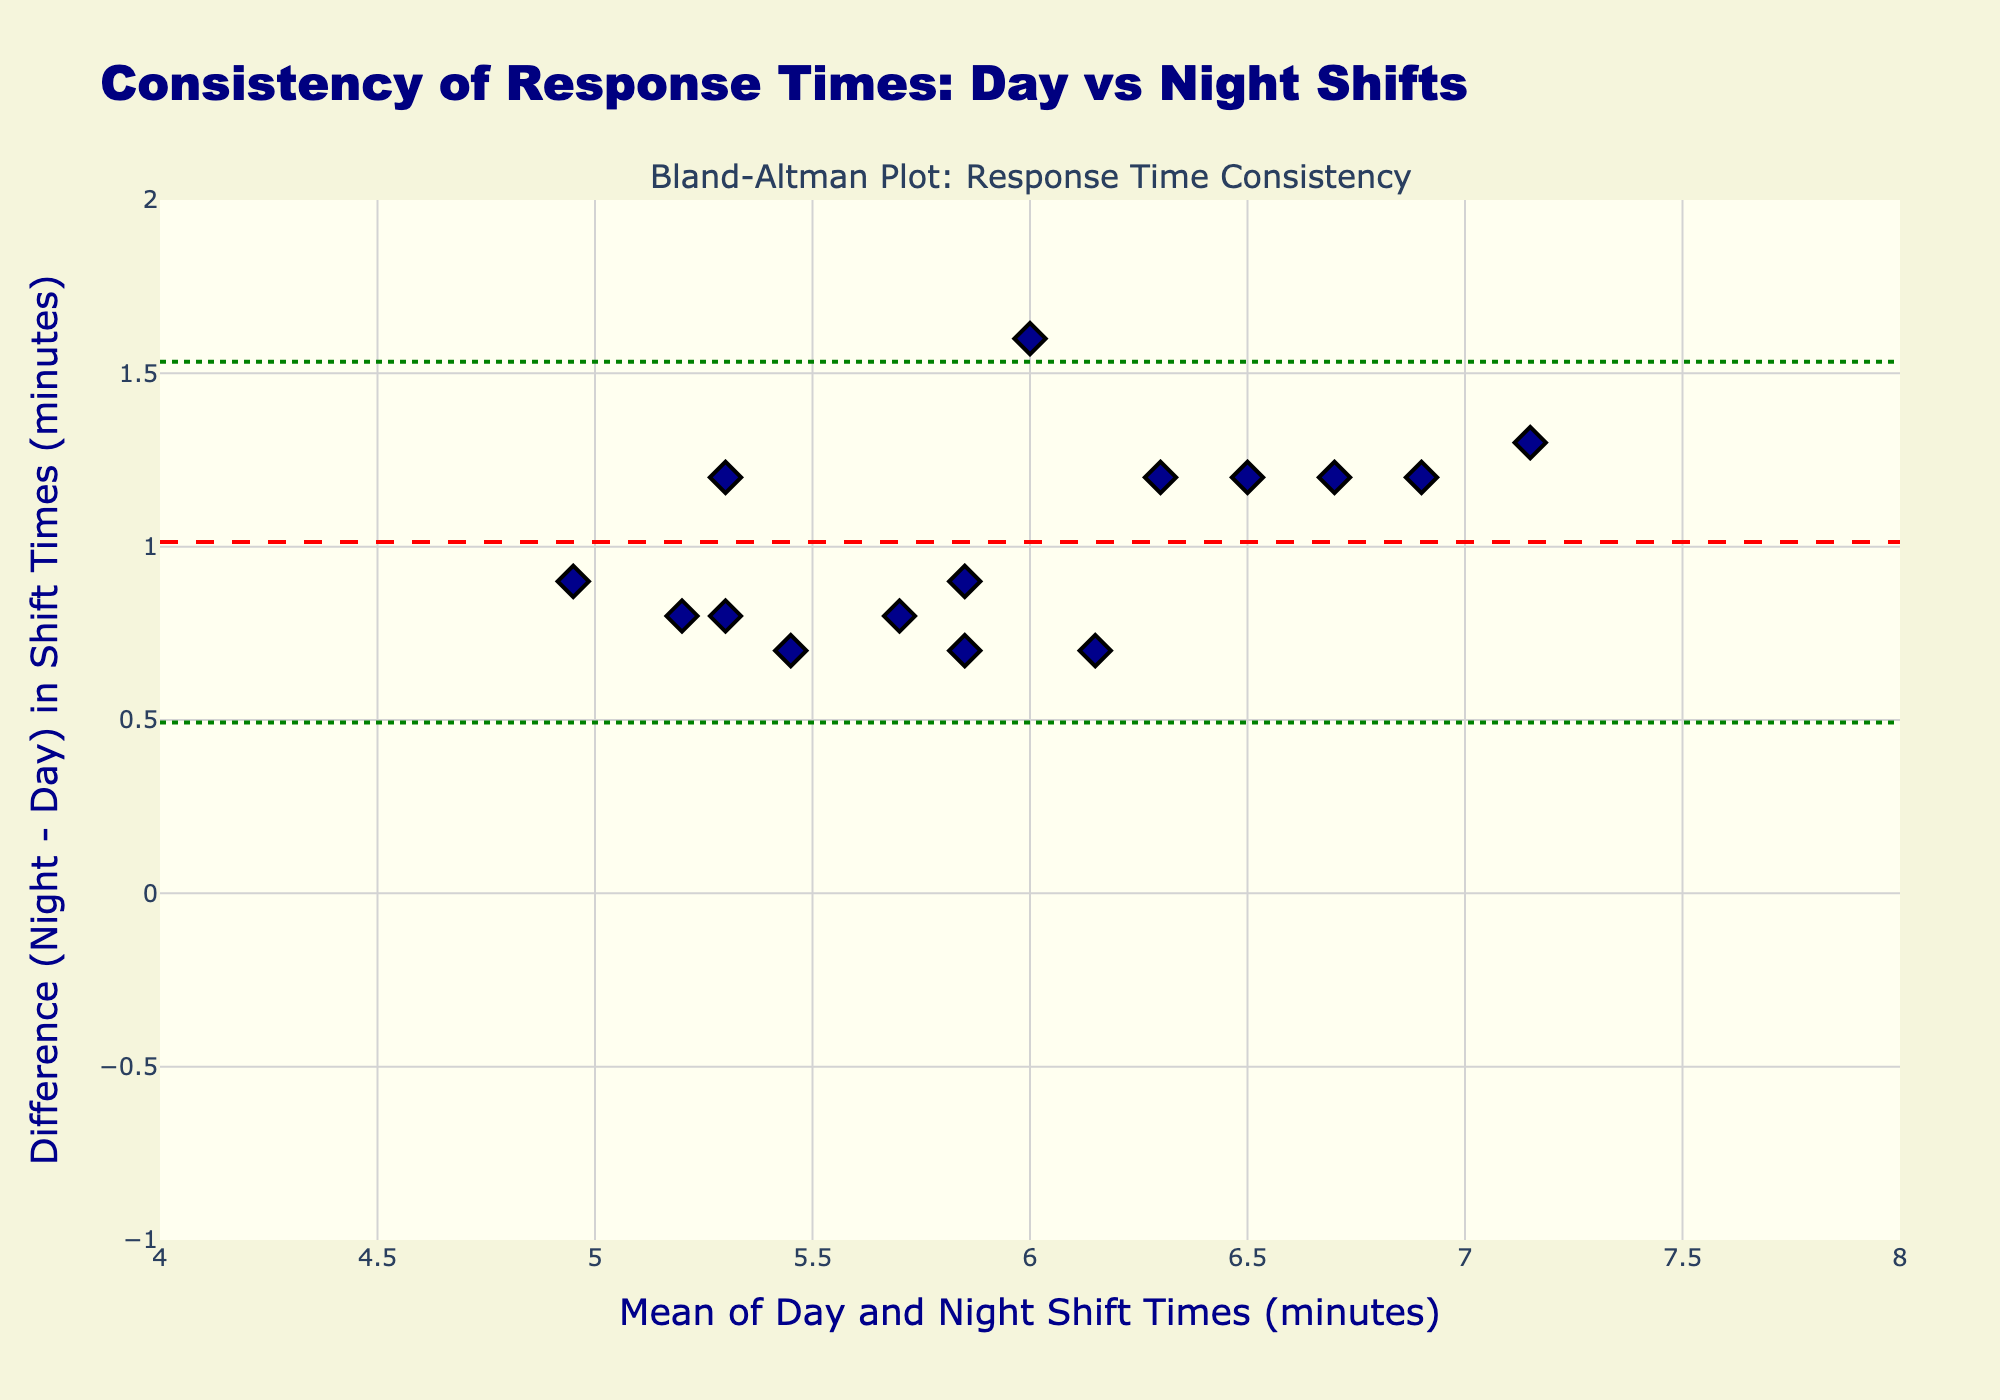What is the title of this plot? The title is located at the top of the figure and is often displayed prominently to describe the nature of the plot's content. Here, it reads "Consistency of Response Times: Day vs Night Shifts".
Answer: Consistency of Response Times: Day vs Night Shifts What are the units on the x-axis and y-axis? The x-axis title mentions "Mean of Day and Night Shift Times (minutes)" and the y-axis title mentions "Difference (Night - Day) in Shift Times (minutes)". Both axes are measured in minutes.
Answer: Minutes How many data points are plotted in the Bland-Altman plot? The data points are the individual markers present in the plot. By counting these markers, we can determine the number of data points. Here, there are 15 markers.
Answer: 15 What is the mean difference between night and day shift times? The mean difference is represented by a dashed red line on the y-axis. Look at the y-coordinate of this line to find the mean difference, which is approximately 1.2 minutes.
Answer: 1.2 What is the range of the 'mean' values on the x-axis? The x-axis range can be identified by observing the start and end values on the x-axis. The values range from approximately 4 to 8 minutes.
Answer: 4 to 8 What does the green dashed line represent? The green dashed lines represent the limits of agreement, defined by the mean difference ± 1.96 times the standard deviation.
Answer: Limits of agreement What are the values for the upper and lower limits of agreement? The upper limit is the sum of the mean difference and 1.96 times the standard deviation, represented by the top green dashed line, approximately 1.6. The lower limit is the difference between the mean difference and 1.96 times the standard deviation, represented by the bottom green dashed line, approximately -0.2.
Answer: Upper: 1.6, Lower: -0.2 What can we infer if most points lie within the limits of agreement? If most data points lie within the limits of agreement (between -0.2 and 1.6), it implies that the response times are consistent between day and night shifts within this range.
Answer: Response times are consistent Are there any data points outside the limits of agreement? Check if any markers fall outside the range of the upper and lower agreement limits (green dashed lines). All points lie within the limits of agreement.
Answer: No Is the overall trend of response time difference between day and night shifts positive or negative? Observe the general positioning of the data points relative to the 0 line on the y-axis. Most points are above the 0 line, indicating a positive trend, where the night shift times are generally longer than the day shift times.
Answer: Positive 